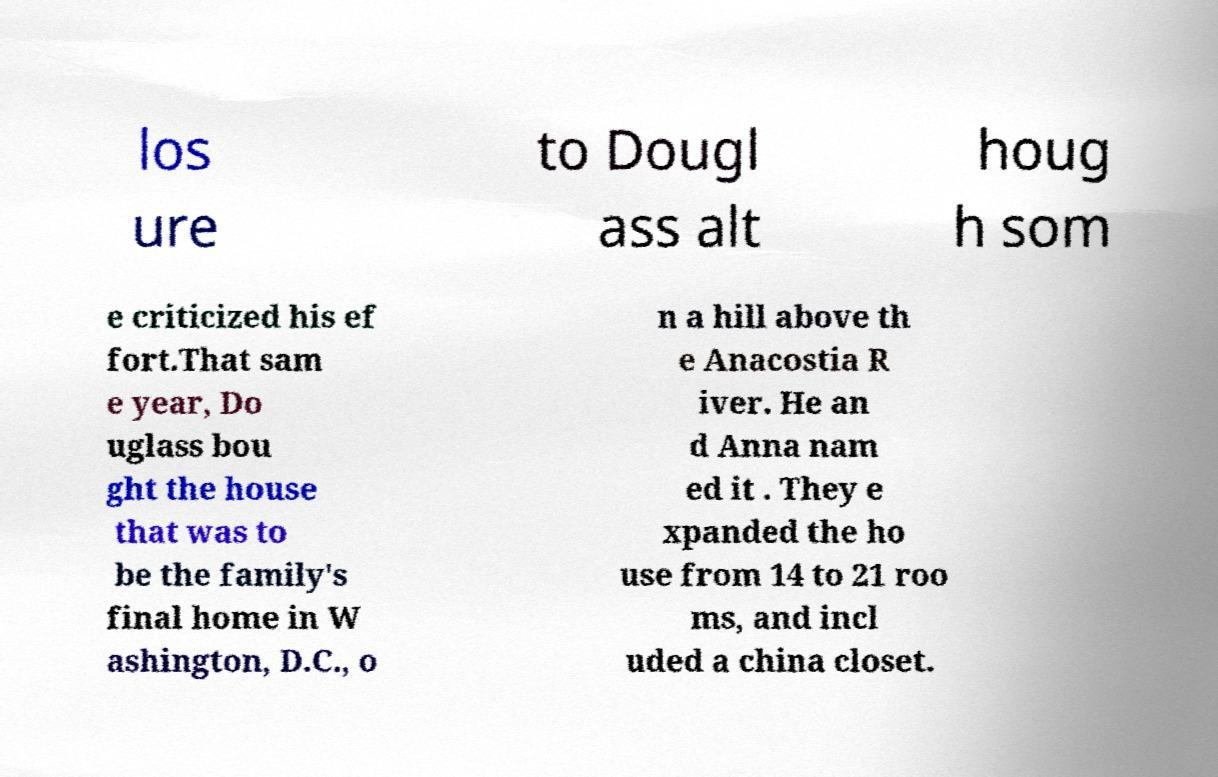I need the written content from this picture converted into text. Can you do that? los ure to Dougl ass alt houg h som e criticized his ef fort.That sam e year, Do uglass bou ght the house that was to be the family's final home in W ashington, D.C., o n a hill above th e Anacostia R iver. He an d Anna nam ed it . They e xpanded the ho use from 14 to 21 roo ms, and incl uded a china closet. 